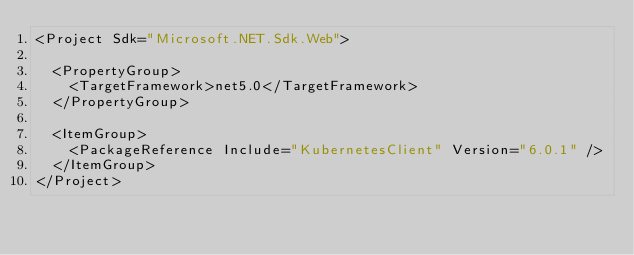<code> <loc_0><loc_0><loc_500><loc_500><_XML_><Project Sdk="Microsoft.NET.Sdk.Web">

  <PropertyGroup>
    <TargetFramework>net5.0</TargetFramework>
  </PropertyGroup>

  <ItemGroup>
    <PackageReference Include="KubernetesClient" Version="6.0.1" />
  </ItemGroup>
</Project>
</code> 